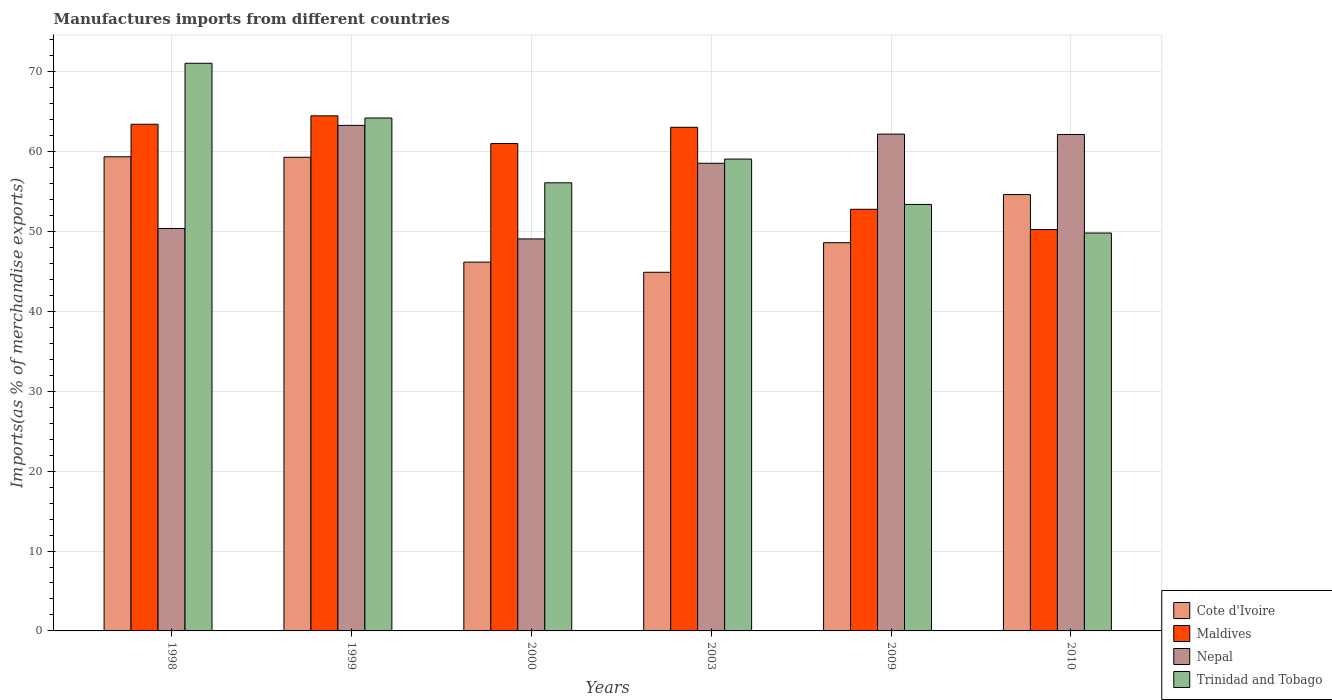How many different coloured bars are there?
Make the answer very short. 4. Are the number of bars per tick equal to the number of legend labels?
Make the answer very short. Yes. Are the number of bars on each tick of the X-axis equal?
Ensure brevity in your answer.  Yes. How many bars are there on the 5th tick from the left?
Your answer should be very brief. 4. What is the label of the 2nd group of bars from the left?
Offer a very short reply. 1999. What is the percentage of imports to different countries in Cote d'Ivoire in 2003?
Ensure brevity in your answer.  44.89. Across all years, what is the maximum percentage of imports to different countries in Cote d'Ivoire?
Offer a very short reply. 59.35. Across all years, what is the minimum percentage of imports to different countries in Nepal?
Keep it short and to the point. 49.07. In which year was the percentage of imports to different countries in Nepal maximum?
Offer a terse response. 1999. What is the total percentage of imports to different countries in Maldives in the graph?
Provide a short and direct response. 354.97. What is the difference between the percentage of imports to different countries in Nepal in 1998 and that in 1999?
Ensure brevity in your answer.  -12.9. What is the difference between the percentage of imports to different countries in Maldives in 1998 and the percentage of imports to different countries in Cote d'Ivoire in 1999?
Make the answer very short. 4.13. What is the average percentage of imports to different countries in Cote d'Ivoire per year?
Offer a terse response. 52.15. In the year 2010, what is the difference between the percentage of imports to different countries in Trinidad and Tobago and percentage of imports to different countries in Cote d'Ivoire?
Your answer should be compact. -4.81. What is the ratio of the percentage of imports to different countries in Trinidad and Tobago in 1998 to that in 2000?
Offer a terse response. 1.27. Is the difference between the percentage of imports to different countries in Trinidad and Tobago in 2009 and 2010 greater than the difference between the percentage of imports to different countries in Cote d'Ivoire in 2009 and 2010?
Provide a succinct answer. Yes. What is the difference between the highest and the second highest percentage of imports to different countries in Trinidad and Tobago?
Make the answer very short. 6.85. What is the difference between the highest and the lowest percentage of imports to different countries in Cote d'Ivoire?
Your answer should be compact. 14.46. Is it the case that in every year, the sum of the percentage of imports to different countries in Trinidad and Tobago and percentage of imports to different countries in Cote d'Ivoire is greater than the sum of percentage of imports to different countries in Maldives and percentage of imports to different countries in Nepal?
Offer a very short reply. No. What does the 3rd bar from the left in 1999 represents?
Your answer should be compact. Nepal. What does the 4th bar from the right in 1998 represents?
Give a very brief answer. Cote d'Ivoire. Is it the case that in every year, the sum of the percentage of imports to different countries in Trinidad and Tobago and percentage of imports to different countries in Cote d'Ivoire is greater than the percentage of imports to different countries in Nepal?
Offer a very short reply. Yes. How many bars are there?
Your response must be concise. 24. Are all the bars in the graph horizontal?
Your answer should be compact. No. How many years are there in the graph?
Provide a short and direct response. 6. Are the values on the major ticks of Y-axis written in scientific E-notation?
Offer a terse response. No. Does the graph contain any zero values?
Make the answer very short. No. Where does the legend appear in the graph?
Your response must be concise. Bottom right. How are the legend labels stacked?
Ensure brevity in your answer.  Vertical. What is the title of the graph?
Offer a terse response. Manufactures imports from different countries. What is the label or title of the Y-axis?
Offer a terse response. Imports(as % of merchandise exports). What is the Imports(as % of merchandise exports) of Cote d'Ivoire in 1998?
Provide a succinct answer. 59.35. What is the Imports(as % of merchandise exports) in Maldives in 1998?
Keep it short and to the point. 63.42. What is the Imports(as % of merchandise exports) in Nepal in 1998?
Your answer should be very brief. 50.38. What is the Imports(as % of merchandise exports) of Trinidad and Tobago in 1998?
Give a very brief answer. 71.06. What is the Imports(as % of merchandise exports) of Cote d'Ivoire in 1999?
Your answer should be very brief. 59.29. What is the Imports(as % of merchandise exports) in Maldives in 1999?
Give a very brief answer. 64.48. What is the Imports(as % of merchandise exports) of Nepal in 1999?
Provide a succinct answer. 63.28. What is the Imports(as % of merchandise exports) in Trinidad and Tobago in 1999?
Provide a succinct answer. 64.2. What is the Imports(as % of merchandise exports) in Cote d'Ivoire in 2000?
Provide a short and direct response. 46.16. What is the Imports(as % of merchandise exports) in Maldives in 2000?
Offer a very short reply. 61.01. What is the Imports(as % of merchandise exports) of Nepal in 2000?
Your answer should be compact. 49.07. What is the Imports(as % of merchandise exports) of Trinidad and Tobago in 2000?
Your answer should be very brief. 56.1. What is the Imports(as % of merchandise exports) of Cote d'Ivoire in 2003?
Your answer should be very brief. 44.89. What is the Imports(as % of merchandise exports) in Maldives in 2003?
Offer a very short reply. 63.04. What is the Imports(as % of merchandise exports) in Nepal in 2003?
Ensure brevity in your answer.  58.54. What is the Imports(as % of merchandise exports) of Trinidad and Tobago in 2003?
Provide a succinct answer. 59.06. What is the Imports(as % of merchandise exports) in Cote d'Ivoire in 2009?
Your response must be concise. 48.6. What is the Imports(as % of merchandise exports) of Maldives in 2009?
Provide a succinct answer. 52.78. What is the Imports(as % of merchandise exports) in Nepal in 2009?
Provide a succinct answer. 62.19. What is the Imports(as % of merchandise exports) in Trinidad and Tobago in 2009?
Your answer should be compact. 53.38. What is the Imports(as % of merchandise exports) in Cote d'Ivoire in 2010?
Provide a succinct answer. 54.62. What is the Imports(as % of merchandise exports) of Maldives in 2010?
Your response must be concise. 50.24. What is the Imports(as % of merchandise exports) in Nepal in 2010?
Provide a succinct answer. 62.14. What is the Imports(as % of merchandise exports) in Trinidad and Tobago in 2010?
Your answer should be compact. 49.81. Across all years, what is the maximum Imports(as % of merchandise exports) of Cote d'Ivoire?
Make the answer very short. 59.35. Across all years, what is the maximum Imports(as % of merchandise exports) in Maldives?
Offer a terse response. 64.48. Across all years, what is the maximum Imports(as % of merchandise exports) of Nepal?
Keep it short and to the point. 63.28. Across all years, what is the maximum Imports(as % of merchandise exports) in Trinidad and Tobago?
Keep it short and to the point. 71.06. Across all years, what is the minimum Imports(as % of merchandise exports) in Cote d'Ivoire?
Your answer should be very brief. 44.89. Across all years, what is the minimum Imports(as % of merchandise exports) of Maldives?
Your response must be concise. 50.24. Across all years, what is the minimum Imports(as % of merchandise exports) of Nepal?
Your answer should be compact. 49.07. Across all years, what is the minimum Imports(as % of merchandise exports) of Trinidad and Tobago?
Offer a terse response. 49.81. What is the total Imports(as % of merchandise exports) of Cote d'Ivoire in the graph?
Keep it short and to the point. 312.92. What is the total Imports(as % of merchandise exports) in Maldives in the graph?
Offer a terse response. 354.97. What is the total Imports(as % of merchandise exports) in Nepal in the graph?
Keep it short and to the point. 345.6. What is the total Imports(as % of merchandise exports) of Trinidad and Tobago in the graph?
Provide a succinct answer. 353.62. What is the difference between the Imports(as % of merchandise exports) in Cote d'Ivoire in 1998 and that in 1999?
Ensure brevity in your answer.  0.06. What is the difference between the Imports(as % of merchandise exports) of Maldives in 1998 and that in 1999?
Offer a terse response. -1.05. What is the difference between the Imports(as % of merchandise exports) in Nepal in 1998 and that in 1999?
Your answer should be very brief. -12.9. What is the difference between the Imports(as % of merchandise exports) in Trinidad and Tobago in 1998 and that in 1999?
Offer a very short reply. 6.85. What is the difference between the Imports(as % of merchandise exports) of Cote d'Ivoire in 1998 and that in 2000?
Offer a terse response. 13.19. What is the difference between the Imports(as % of merchandise exports) of Maldives in 1998 and that in 2000?
Offer a terse response. 2.41. What is the difference between the Imports(as % of merchandise exports) in Nepal in 1998 and that in 2000?
Make the answer very short. 1.31. What is the difference between the Imports(as % of merchandise exports) of Trinidad and Tobago in 1998 and that in 2000?
Offer a terse response. 14.96. What is the difference between the Imports(as % of merchandise exports) in Cote d'Ivoire in 1998 and that in 2003?
Keep it short and to the point. 14.46. What is the difference between the Imports(as % of merchandise exports) in Maldives in 1998 and that in 2003?
Provide a succinct answer. 0.38. What is the difference between the Imports(as % of merchandise exports) in Nepal in 1998 and that in 2003?
Provide a succinct answer. -8.16. What is the difference between the Imports(as % of merchandise exports) of Trinidad and Tobago in 1998 and that in 2003?
Offer a very short reply. 11.99. What is the difference between the Imports(as % of merchandise exports) in Cote d'Ivoire in 1998 and that in 2009?
Make the answer very short. 10.76. What is the difference between the Imports(as % of merchandise exports) of Maldives in 1998 and that in 2009?
Provide a succinct answer. 10.64. What is the difference between the Imports(as % of merchandise exports) in Nepal in 1998 and that in 2009?
Give a very brief answer. -11.81. What is the difference between the Imports(as % of merchandise exports) in Trinidad and Tobago in 1998 and that in 2009?
Make the answer very short. 17.67. What is the difference between the Imports(as % of merchandise exports) of Cote d'Ivoire in 1998 and that in 2010?
Keep it short and to the point. 4.73. What is the difference between the Imports(as % of merchandise exports) in Maldives in 1998 and that in 2010?
Your answer should be very brief. 13.18. What is the difference between the Imports(as % of merchandise exports) of Nepal in 1998 and that in 2010?
Offer a terse response. -11.77. What is the difference between the Imports(as % of merchandise exports) in Trinidad and Tobago in 1998 and that in 2010?
Provide a succinct answer. 21.25. What is the difference between the Imports(as % of merchandise exports) of Cote d'Ivoire in 1999 and that in 2000?
Your answer should be compact. 13.13. What is the difference between the Imports(as % of merchandise exports) of Maldives in 1999 and that in 2000?
Keep it short and to the point. 3.47. What is the difference between the Imports(as % of merchandise exports) of Nepal in 1999 and that in 2000?
Offer a terse response. 14.21. What is the difference between the Imports(as % of merchandise exports) of Trinidad and Tobago in 1999 and that in 2000?
Your answer should be very brief. 8.11. What is the difference between the Imports(as % of merchandise exports) of Cote d'Ivoire in 1999 and that in 2003?
Offer a very short reply. 14.4. What is the difference between the Imports(as % of merchandise exports) of Maldives in 1999 and that in 2003?
Your answer should be very brief. 1.44. What is the difference between the Imports(as % of merchandise exports) of Nepal in 1999 and that in 2003?
Provide a succinct answer. 4.74. What is the difference between the Imports(as % of merchandise exports) of Trinidad and Tobago in 1999 and that in 2003?
Your answer should be very brief. 5.14. What is the difference between the Imports(as % of merchandise exports) in Cote d'Ivoire in 1999 and that in 2009?
Provide a short and direct response. 10.69. What is the difference between the Imports(as % of merchandise exports) of Maldives in 1999 and that in 2009?
Your answer should be compact. 11.7. What is the difference between the Imports(as % of merchandise exports) of Nepal in 1999 and that in 2009?
Offer a very short reply. 1.09. What is the difference between the Imports(as % of merchandise exports) in Trinidad and Tobago in 1999 and that in 2009?
Your answer should be very brief. 10.82. What is the difference between the Imports(as % of merchandise exports) of Cote d'Ivoire in 1999 and that in 2010?
Your answer should be very brief. 4.67. What is the difference between the Imports(as % of merchandise exports) in Maldives in 1999 and that in 2010?
Offer a terse response. 14.23. What is the difference between the Imports(as % of merchandise exports) of Nepal in 1999 and that in 2010?
Your answer should be very brief. 1.14. What is the difference between the Imports(as % of merchandise exports) in Trinidad and Tobago in 1999 and that in 2010?
Provide a succinct answer. 14.39. What is the difference between the Imports(as % of merchandise exports) of Cote d'Ivoire in 2000 and that in 2003?
Ensure brevity in your answer.  1.27. What is the difference between the Imports(as % of merchandise exports) in Maldives in 2000 and that in 2003?
Your response must be concise. -2.03. What is the difference between the Imports(as % of merchandise exports) in Nepal in 2000 and that in 2003?
Your answer should be compact. -9.47. What is the difference between the Imports(as % of merchandise exports) of Trinidad and Tobago in 2000 and that in 2003?
Your response must be concise. -2.97. What is the difference between the Imports(as % of merchandise exports) of Cote d'Ivoire in 2000 and that in 2009?
Your answer should be compact. -2.43. What is the difference between the Imports(as % of merchandise exports) of Maldives in 2000 and that in 2009?
Offer a very short reply. 8.23. What is the difference between the Imports(as % of merchandise exports) of Nepal in 2000 and that in 2009?
Your answer should be compact. -13.12. What is the difference between the Imports(as % of merchandise exports) in Trinidad and Tobago in 2000 and that in 2009?
Offer a very short reply. 2.71. What is the difference between the Imports(as % of merchandise exports) of Cote d'Ivoire in 2000 and that in 2010?
Offer a very short reply. -8.46. What is the difference between the Imports(as % of merchandise exports) of Maldives in 2000 and that in 2010?
Keep it short and to the point. 10.77. What is the difference between the Imports(as % of merchandise exports) of Nepal in 2000 and that in 2010?
Offer a terse response. -13.07. What is the difference between the Imports(as % of merchandise exports) of Trinidad and Tobago in 2000 and that in 2010?
Ensure brevity in your answer.  6.28. What is the difference between the Imports(as % of merchandise exports) of Cote d'Ivoire in 2003 and that in 2009?
Ensure brevity in your answer.  -3.7. What is the difference between the Imports(as % of merchandise exports) in Maldives in 2003 and that in 2009?
Offer a very short reply. 10.26. What is the difference between the Imports(as % of merchandise exports) in Nepal in 2003 and that in 2009?
Give a very brief answer. -3.65. What is the difference between the Imports(as % of merchandise exports) of Trinidad and Tobago in 2003 and that in 2009?
Offer a terse response. 5.68. What is the difference between the Imports(as % of merchandise exports) in Cote d'Ivoire in 2003 and that in 2010?
Give a very brief answer. -9.73. What is the difference between the Imports(as % of merchandise exports) in Maldives in 2003 and that in 2010?
Offer a very short reply. 12.8. What is the difference between the Imports(as % of merchandise exports) of Nepal in 2003 and that in 2010?
Your answer should be very brief. -3.6. What is the difference between the Imports(as % of merchandise exports) of Trinidad and Tobago in 2003 and that in 2010?
Your answer should be compact. 9.25. What is the difference between the Imports(as % of merchandise exports) of Cote d'Ivoire in 2009 and that in 2010?
Make the answer very short. -6.03. What is the difference between the Imports(as % of merchandise exports) of Maldives in 2009 and that in 2010?
Give a very brief answer. 2.54. What is the difference between the Imports(as % of merchandise exports) of Nepal in 2009 and that in 2010?
Give a very brief answer. 0.04. What is the difference between the Imports(as % of merchandise exports) in Trinidad and Tobago in 2009 and that in 2010?
Offer a terse response. 3.57. What is the difference between the Imports(as % of merchandise exports) in Cote d'Ivoire in 1998 and the Imports(as % of merchandise exports) in Maldives in 1999?
Offer a terse response. -5.12. What is the difference between the Imports(as % of merchandise exports) of Cote d'Ivoire in 1998 and the Imports(as % of merchandise exports) of Nepal in 1999?
Your answer should be very brief. -3.93. What is the difference between the Imports(as % of merchandise exports) in Cote d'Ivoire in 1998 and the Imports(as % of merchandise exports) in Trinidad and Tobago in 1999?
Provide a short and direct response. -4.85. What is the difference between the Imports(as % of merchandise exports) of Maldives in 1998 and the Imports(as % of merchandise exports) of Nepal in 1999?
Your response must be concise. 0.14. What is the difference between the Imports(as % of merchandise exports) of Maldives in 1998 and the Imports(as % of merchandise exports) of Trinidad and Tobago in 1999?
Your answer should be compact. -0.78. What is the difference between the Imports(as % of merchandise exports) of Nepal in 1998 and the Imports(as % of merchandise exports) of Trinidad and Tobago in 1999?
Offer a terse response. -13.83. What is the difference between the Imports(as % of merchandise exports) of Cote d'Ivoire in 1998 and the Imports(as % of merchandise exports) of Maldives in 2000?
Ensure brevity in your answer.  -1.66. What is the difference between the Imports(as % of merchandise exports) in Cote d'Ivoire in 1998 and the Imports(as % of merchandise exports) in Nepal in 2000?
Your answer should be compact. 10.28. What is the difference between the Imports(as % of merchandise exports) in Cote d'Ivoire in 1998 and the Imports(as % of merchandise exports) in Trinidad and Tobago in 2000?
Your answer should be very brief. 3.26. What is the difference between the Imports(as % of merchandise exports) in Maldives in 1998 and the Imports(as % of merchandise exports) in Nepal in 2000?
Give a very brief answer. 14.35. What is the difference between the Imports(as % of merchandise exports) of Maldives in 1998 and the Imports(as % of merchandise exports) of Trinidad and Tobago in 2000?
Ensure brevity in your answer.  7.33. What is the difference between the Imports(as % of merchandise exports) of Nepal in 1998 and the Imports(as % of merchandise exports) of Trinidad and Tobago in 2000?
Offer a very short reply. -5.72. What is the difference between the Imports(as % of merchandise exports) in Cote d'Ivoire in 1998 and the Imports(as % of merchandise exports) in Maldives in 2003?
Ensure brevity in your answer.  -3.69. What is the difference between the Imports(as % of merchandise exports) of Cote d'Ivoire in 1998 and the Imports(as % of merchandise exports) of Nepal in 2003?
Ensure brevity in your answer.  0.81. What is the difference between the Imports(as % of merchandise exports) in Cote d'Ivoire in 1998 and the Imports(as % of merchandise exports) in Trinidad and Tobago in 2003?
Your response must be concise. 0.29. What is the difference between the Imports(as % of merchandise exports) of Maldives in 1998 and the Imports(as % of merchandise exports) of Nepal in 2003?
Keep it short and to the point. 4.88. What is the difference between the Imports(as % of merchandise exports) in Maldives in 1998 and the Imports(as % of merchandise exports) in Trinidad and Tobago in 2003?
Make the answer very short. 4.36. What is the difference between the Imports(as % of merchandise exports) in Nepal in 1998 and the Imports(as % of merchandise exports) in Trinidad and Tobago in 2003?
Keep it short and to the point. -8.69. What is the difference between the Imports(as % of merchandise exports) of Cote d'Ivoire in 1998 and the Imports(as % of merchandise exports) of Maldives in 2009?
Your response must be concise. 6.57. What is the difference between the Imports(as % of merchandise exports) in Cote d'Ivoire in 1998 and the Imports(as % of merchandise exports) in Nepal in 2009?
Give a very brief answer. -2.83. What is the difference between the Imports(as % of merchandise exports) in Cote d'Ivoire in 1998 and the Imports(as % of merchandise exports) in Trinidad and Tobago in 2009?
Provide a succinct answer. 5.97. What is the difference between the Imports(as % of merchandise exports) of Maldives in 1998 and the Imports(as % of merchandise exports) of Nepal in 2009?
Provide a short and direct response. 1.24. What is the difference between the Imports(as % of merchandise exports) in Maldives in 1998 and the Imports(as % of merchandise exports) in Trinidad and Tobago in 2009?
Ensure brevity in your answer.  10.04. What is the difference between the Imports(as % of merchandise exports) of Nepal in 1998 and the Imports(as % of merchandise exports) of Trinidad and Tobago in 2009?
Offer a very short reply. -3.01. What is the difference between the Imports(as % of merchandise exports) in Cote d'Ivoire in 1998 and the Imports(as % of merchandise exports) in Maldives in 2010?
Ensure brevity in your answer.  9.11. What is the difference between the Imports(as % of merchandise exports) of Cote d'Ivoire in 1998 and the Imports(as % of merchandise exports) of Nepal in 2010?
Your answer should be compact. -2.79. What is the difference between the Imports(as % of merchandise exports) of Cote d'Ivoire in 1998 and the Imports(as % of merchandise exports) of Trinidad and Tobago in 2010?
Offer a very short reply. 9.54. What is the difference between the Imports(as % of merchandise exports) in Maldives in 1998 and the Imports(as % of merchandise exports) in Nepal in 2010?
Your answer should be very brief. 1.28. What is the difference between the Imports(as % of merchandise exports) of Maldives in 1998 and the Imports(as % of merchandise exports) of Trinidad and Tobago in 2010?
Provide a short and direct response. 13.61. What is the difference between the Imports(as % of merchandise exports) of Nepal in 1998 and the Imports(as % of merchandise exports) of Trinidad and Tobago in 2010?
Provide a succinct answer. 0.57. What is the difference between the Imports(as % of merchandise exports) of Cote d'Ivoire in 1999 and the Imports(as % of merchandise exports) of Maldives in 2000?
Your answer should be compact. -1.72. What is the difference between the Imports(as % of merchandise exports) in Cote d'Ivoire in 1999 and the Imports(as % of merchandise exports) in Nepal in 2000?
Offer a very short reply. 10.22. What is the difference between the Imports(as % of merchandise exports) of Cote d'Ivoire in 1999 and the Imports(as % of merchandise exports) of Trinidad and Tobago in 2000?
Make the answer very short. 3.2. What is the difference between the Imports(as % of merchandise exports) in Maldives in 1999 and the Imports(as % of merchandise exports) in Nepal in 2000?
Your response must be concise. 15.41. What is the difference between the Imports(as % of merchandise exports) in Maldives in 1999 and the Imports(as % of merchandise exports) in Trinidad and Tobago in 2000?
Provide a succinct answer. 8.38. What is the difference between the Imports(as % of merchandise exports) in Nepal in 1999 and the Imports(as % of merchandise exports) in Trinidad and Tobago in 2000?
Your answer should be very brief. 7.19. What is the difference between the Imports(as % of merchandise exports) in Cote d'Ivoire in 1999 and the Imports(as % of merchandise exports) in Maldives in 2003?
Your answer should be very brief. -3.75. What is the difference between the Imports(as % of merchandise exports) of Cote d'Ivoire in 1999 and the Imports(as % of merchandise exports) of Nepal in 2003?
Offer a very short reply. 0.75. What is the difference between the Imports(as % of merchandise exports) of Cote d'Ivoire in 1999 and the Imports(as % of merchandise exports) of Trinidad and Tobago in 2003?
Your answer should be very brief. 0.23. What is the difference between the Imports(as % of merchandise exports) in Maldives in 1999 and the Imports(as % of merchandise exports) in Nepal in 2003?
Offer a terse response. 5.94. What is the difference between the Imports(as % of merchandise exports) in Maldives in 1999 and the Imports(as % of merchandise exports) in Trinidad and Tobago in 2003?
Give a very brief answer. 5.41. What is the difference between the Imports(as % of merchandise exports) in Nepal in 1999 and the Imports(as % of merchandise exports) in Trinidad and Tobago in 2003?
Ensure brevity in your answer.  4.22. What is the difference between the Imports(as % of merchandise exports) in Cote d'Ivoire in 1999 and the Imports(as % of merchandise exports) in Maldives in 2009?
Give a very brief answer. 6.51. What is the difference between the Imports(as % of merchandise exports) of Cote d'Ivoire in 1999 and the Imports(as % of merchandise exports) of Nepal in 2009?
Offer a terse response. -2.9. What is the difference between the Imports(as % of merchandise exports) in Cote d'Ivoire in 1999 and the Imports(as % of merchandise exports) in Trinidad and Tobago in 2009?
Your answer should be very brief. 5.91. What is the difference between the Imports(as % of merchandise exports) in Maldives in 1999 and the Imports(as % of merchandise exports) in Nepal in 2009?
Provide a short and direct response. 2.29. What is the difference between the Imports(as % of merchandise exports) of Maldives in 1999 and the Imports(as % of merchandise exports) of Trinidad and Tobago in 2009?
Provide a succinct answer. 11.09. What is the difference between the Imports(as % of merchandise exports) of Nepal in 1999 and the Imports(as % of merchandise exports) of Trinidad and Tobago in 2009?
Offer a terse response. 9.9. What is the difference between the Imports(as % of merchandise exports) in Cote d'Ivoire in 1999 and the Imports(as % of merchandise exports) in Maldives in 2010?
Your answer should be compact. 9.05. What is the difference between the Imports(as % of merchandise exports) of Cote d'Ivoire in 1999 and the Imports(as % of merchandise exports) of Nepal in 2010?
Offer a terse response. -2.85. What is the difference between the Imports(as % of merchandise exports) of Cote d'Ivoire in 1999 and the Imports(as % of merchandise exports) of Trinidad and Tobago in 2010?
Ensure brevity in your answer.  9.48. What is the difference between the Imports(as % of merchandise exports) of Maldives in 1999 and the Imports(as % of merchandise exports) of Nepal in 2010?
Ensure brevity in your answer.  2.33. What is the difference between the Imports(as % of merchandise exports) of Maldives in 1999 and the Imports(as % of merchandise exports) of Trinidad and Tobago in 2010?
Make the answer very short. 14.67. What is the difference between the Imports(as % of merchandise exports) of Nepal in 1999 and the Imports(as % of merchandise exports) of Trinidad and Tobago in 2010?
Offer a very short reply. 13.47. What is the difference between the Imports(as % of merchandise exports) in Cote d'Ivoire in 2000 and the Imports(as % of merchandise exports) in Maldives in 2003?
Your answer should be compact. -16.88. What is the difference between the Imports(as % of merchandise exports) in Cote d'Ivoire in 2000 and the Imports(as % of merchandise exports) in Nepal in 2003?
Provide a short and direct response. -12.38. What is the difference between the Imports(as % of merchandise exports) of Cote d'Ivoire in 2000 and the Imports(as % of merchandise exports) of Trinidad and Tobago in 2003?
Your response must be concise. -12.9. What is the difference between the Imports(as % of merchandise exports) of Maldives in 2000 and the Imports(as % of merchandise exports) of Nepal in 2003?
Make the answer very short. 2.47. What is the difference between the Imports(as % of merchandise exports) of Maldives in 2000 and the Imports(as % of merchandise exports) of Trinidad and Tobago in 2003?
Your answer should be compact. 1.94. What is the difference between the Imports(as % of merchandise exports) in Nepal in 2000 and the Imports(as % of merchandise exports) in Trinidad and Tobago in 2003?
Provide a short and direct response. -9.99. What is the difference between the Imports(as % of merchandise exports) in Cote d'Ivoire in 2000 and the Imports(as % of merchandise exports) in Maldives in 2009?
Your answer should be compact. -6.62. What is the difference between the Imports(as % of merchandise exports) in Cote d'Ivoire in 2000 and the Imports(as % of merchandise exports) in Nepal in 2009?
Provide a short and direct response. -16.02. What is the difference between the Imports(as % of merchandise exports) of Cote d'Ivoire in 2000 and the Imports(as % of merchandise exports) of Trinidad and Tobago in 2009?
Provide a short and direct response. -7.22. What is the difference between the Imports(as % of merchandise exports) of Maldives in 2000 and the Imports(as % of merchandise exports) of Nepal in 2009?
Your response must be concise. -1.18. What is the difference between the Imports(as % of merchandise exports) of Maldives in 2000 and the Imports(as % of merchandise exports) of Trinidad and Tobago in 2009?
Provide a short and direct response. 7.62. What is the difference between the Imports(as % of merchandise exports) of Nepal in 2000 and the Imports(as % of merchandise exports) of Trinidad and Tobago in 2009?
Your answer should be compact. -4.31. What is the difference between the Imports(as % of merchandise exports) of Cote d'Ivoire in 2000 and the Imports(as % of merchandise exports) of Maldives in 2010?
Ensure brevity in your answer.  -4.08. What is the difference between the Imports(as % of merchandise exports) of Cote d'Ivoire in 2000 and the Imports(as % of merchandise exports) of Nepal in 2010?
Make the answer very short. -15.98. What is the difference between the Imports(as % of merchandise exports) of Cote d'Ivoire in 2000 and the Imports(as % of merchandise exports) of Trinidad and Tobago in 2010?
Offer a terse response. -3.65. What is the difference between the Imports(as % of merchandise exports) of Maldives in 2000 and the Imports(as % of merchandise exports) of Nepal in 2010?
Keep it short and to the point. -1.13. What is the difference between the Imports(as % of merchandise exports) of Maldives in 2000 and the Imports(as % of merchandise exports) of Trinidad and Tobago in 2010?
Make the answer very short. 11.2. What is the difference between the Imports(as % of merchandise exports) of Nepal in 2000 and the Imports(as % of merchandise exports) of Trinidad and Tobago in 2010?
Your answer should be compact. -0.74. What is the difference between the Imports(as % of merchandise exports) of Cote d'Ivoire in 2003 and the Imports(as % of merchandise exports) of Maldives in 2009?
Give a very brief answer. -7.89. What is the difference between the Imports(as % of merchandise exports) in Cote d'Ivoire in 2003 and the Imports(as % of merchandise exports) in Nepal in 2009?
Your answer should be compact. -17.29. What is the difference between the Imports(as % of merchandise exports) in Cote d'Ivoire in 2003 and the Imports(as % of merchandise exports) in Trinidad and Tobago in 2009?
Provide a succinct answer. -8.49. What is the difference between the Imports(as % of merchandise exports) of Maldives in 2003 and the Imports(as % of merchandise exports) of Nepal in 2009?
Offer a very short reply. 0.85. What is the difference between the Imports(as % of merchandise exports) in Maldives in 2003 and the Imports(as % of merchandise exports) in Trinidad and Tobago in 2009?
Your answer should be compact. 9.66. What is the difference between the Imports(as % of merchandise exports) in Nepal in 2003 and the Imports(as % of merchandise exports) in Trinidad and Tobago in 2009?
Make the answer very short. 5.16. What is the difference between the Imports(as % of merchandise exports) in Cote d'Ivoire in 2003 and the Imports(as % of merchandise exports) in Maldives in 2010?
Your answer should be compact. -5.35. What is the difference between the Imports(as % of merchandise exports) of Cote d'Ivoire in 2003 and the Imports(as % of merchandise exports) of Nepal in 2010?
Your response must be concise. -17.25. What is the difference between the Imports(as % of merchandise exports) in Cote d'Ivoire in 2003 and the Imports(as % of merchandise exports) in Trinidad and Tobago in 2010?
Give a very brief answer. -4.92. What is the difference between the Imports(as % of merchandise exports) in Maldives in 2003 and the Imports(as % of merchandise exports) in Nepal in 2010?
Make the answer very short. 0.9. What is the difference between the Imports(as % of merchandise exports) in Maldives in 2003 and the Imports(as % of merchandise exports) in Trinidad and Tobago in 2010?
Ensure brevity in your answer.  13.23. What is the difference between the Imports(as % of merchandise exports) in Nepal in 2003 and the Imports(as % of merchandise exports) in Trinidad and Tobago in 2010?
Provide a short and direct response. 8.73. What is the difference between the Imports(as % of merchandise exports) in Cote d'Ivoire in 2009 and the Imports(as % of merchandise exports) in Maldives in 2010?
Offer a very short reply. -1.65. What is the difference between the Imports(as % of merchandise exports) in Cote d'Ivoire in 2009 and the Imports(as % of merchandise exports) in Nepal in 2010?
Give a very brief answer. -13.55. What is the difference between the Imports(as % of merchandise exports) of Cote d'Ivoire in 2009 and the Imports(as % of merchandise exports) of Trinidad and Tobago in 2010?
Provide a succinct answer. -1.21. What is the difference between the Imports(as % of merchandise exports) of Maldives in 2009 and the Imports(as % of merchandise exports) of Nepal in 2010?
Provide a short and direct response. -9.36. What is the difference between the Imports(as % of merchandise exports) of Maldives in 2009 and the Imports(as % of merchandise exports) of Trinidad and Tobago in 2010?
Offer a very short reply. 2.97. What is the difference between the Imports(as % of merchandise exports) of Nepal in 2009 and the Imports(as % of merchandise exports) of Trinidad and Tobago in 2010?
Your answer should be compact. 12.38. What is the average Imports(as % of merchandise exports) of Cote d'Ivoire per year?
Provide a short and direct response. 52.15. What is the average Imports(as % of merchandise exports) in Maldives per year?
Keep it short and to the point. 59.16. What is the average Imports(as % of merchandise exports) of Nepal per year?
Provide a succinct answer. 57.6. What is the average Imports(as % of merchandise exports) of Trinidad and Tobago per year?
Your answer should be very brief. 58.94. In the year 1998, what is the difference between the Imports(as % of merchandise exports) of Cote d'Ivoire and Imports(as % of merchandise exports) of Maldives?
Offer a terse response. -4.07. In the year 1998, what is the difference between the Imports(as % of merchandise exports) in Cote d'Ivoire and Imports(as % of merchandise exports) in Nepal?
Your response must be concise. 8.98. In the year 1998, what is the difference between the Imports(as % of merchandise exports) in Cote d'Ivoire and Imports(as % of merchandise exports) in Trinidad and Tobago?
Keep it short and to the point. -11.71. In the year 1998, what is the difference between the Imports(as % of merchandise exports) in Maldives and Imports(as % of merchandise exports) in Nepal?
Your response must be concise. 13.04. In the year 1998, what is the difference between the Imports(as % of merchandise exports) of Maldives and Imports(as % of merchandise exports) of Trinidad and Tobago?
Provide a short and direct response. -7.64. In the year 1998, what is the difference between the Imports(as % of merchandise exports) in Nepal and Imports(as % of merchandise exports) in Trinidad and Tobago?
Your answer should be compact. -20.68. In the year 1999, what is the difference between the Imports(as % of merchandise exports) of Cote d'Ivoire and Imports(as % of merchandise exports) of Maldives?
Offer a terse response. -5.19. In the year 1999, what is the difference between the Imports(as % of merchandise exports) in Cote d'Ivoire and Imports(as % of merchandise exports) in Nepal?
Provide a short and direct response. -3.99. In the year 1999, what is the difference between the Imports(as % of merchandise exports) of Cote d'Ivoire and Imports(as % of merchandise exports) of Trinidad and Tobago?
Offer a very short reply. -4.91. In the year 1999, what is the difference between the Imports(as % of merchandise exports) in Maldives and Imports(as % of merchandise exports) in Nepal?
Give a very brief answer. 1.19. In the year 1999, what is the difference between the Imports(as % of merchandise exports) of Maldives and Imports(as % of merchandise exports) of Trinidad and Tobago?
Your response must be concise. 0.27. In the year 1999, what is the difference between the Imports(as % of merchandise exports) of Nepal and Imports(as % of merchandise exports) of Trinidad and Tobago?
Give a very brief answer. -0.92. In the year 2000, what is the difference between the Imports(as % of merchandise exports) of Cote d'Ivoire and Imports(as % of merchandise exports) of Maldives?
Provide a short and direct response. -14.85. In the year 2000, what is the difference between the Imports(as % of merchandise exports) in Cote d'Ivoire and Imports(as % of merchandise exports) in Nepal?
Your answer should be compact. -2.91. In the year 2000, what is the difference between the Imports(as % of merchandise exports) in Cote d'Ivoire and Imports(as % of merchandise exports) in Trinidad and Tobago?
Provide a short and direct response. -9.93. In the year 2000, what is the difference between the Imports(as % of merchandise exports) of Maldives and Imports(as % of merchandise exports) of Nepal?
Give a very brief answer. 11.94. In the year 2000, what is the difference between the Imports(as % of merchandise exports) of Maldives and Imports(as % of merchandise exports) of Trinidad and Tobago?
Keep it short and to the point. 4.91. In the year 2000, what is the difference between the Imports(as % of merchandise exports) in Nepal and Imports(as % of merchandise exports) in Trinidad and Tobago?
Make the answer very short. -7.03. In the year 2003, what is the difference between the Imports(as % of merchandise exports) in Cote d'Ivoire and Imports(as % of merchandise exports) in Maldives?
Keep it short and to the point. -18.15. In the year 2003, what is the difference between the Imports(as % of merchandise exports) of Cote d'Ivoire and Imports(as % of merchandise exports) of Nepal?
Ensure brevity in your answer.  -13.65. In the year 2003, what is the difference between the Imports(as % of merchandise exports) in Cote d'Ivoire and Imports(as % of merchandise exports) in Trinidad and Tobago?
Make the answer very short. -14.17. In the year 2003, what is the difference between the Imports(as % of merchandise exports) of Maldives and Imports(as % of merchandise exports) of Nepal?
Give a very brief answer. 4.5. In the year 2003, what is the difference between the Imports(as % of merchandise exports) in Maldives and Imports(as % of merchandise exports) in Trinidad and Tobago?
Offer a very short reply. 3.98. In the year 2003, what is the difference between the Imports(as % of merchandise exports) of Nepal and Imports(as % of merchandise exports) of Trinidad and Tobago?
Your answer should be very brief. -0.52. In the year 2009, what is the difference between the Imports(as % of merchandise exports) of Cote d'Ivoire and Imports(as % of merchandise exports) of Maldives?
Your answer should be compact. -4.18. In the year 2009, what is the difference between the Imports(as % of merchandise exports) in Cote d'Ivoire and Imports(as % of merchandise exports) in Nepal?
Ensure brevity in your answer.  -13.59. In the year 2009, what is the difference between the Imports(as % of merchandise exports) in Cote d'Ivoire and Imports(as % of merchandise exports) in Trinidad and Tobago?
Ensure brevity in your answer.  -4.79. In the year 2009, what is the difference between the Imports(as % of merchandise exports) in Maldives and Imports(as % of merchandise exports) in Nepal?
Your response must be concise. -9.41. In the year 2009, what is the difference between the Imports(as % of merchandise exports) of Maldives and Imports(as % of merchandise exports) of Trinidad and Tobago?
Your response must be concise. -0.61. In the year 2009, what is the difference between the Imports(as % of merchandise exports) in Nepal and Imports(as % of merchandise exports) in Trinidad and Tobago?
Your answer should be very brief. 8.8. In the year 2010, what is the difference between the Imports(as % of merchandise exports) in Cote d'Ivoire and Imports(as % of merchandise exports) in Maldives?
Ensure brevity in your answer.  4.38. In the year 2010, what is the difference between the Imports(as % of merchandise exports) in Cote d'Ivoire and Imports(as % of merchandise exports) in Nepal?
Your answer should be very brief. -7.52. In the year 2010, what is the difference between the Imports(as % of merchandise exports) of Cote d'Ivoire and Imports(as % of merchandise exports) of Trinidad and Tobago?
Give a very brief answer. 4.81. In the year 2010, what is the difference between the Imports(as % of merchandise exports) of Maldives and Imports(as % of merchandise exports) of Nepal?
Offer a terse response. -11.9. In the year 2010, what is the difference between the Imports(as % of merchandise exports) in Maldives and Imports(as % of merchandise exports) in Trinidad and Tobago?
Your response must be concise. 0.43. In the year 2010, what is the difference between the Imports(as % of merchandise exports) of Nepal and Imports(as % of merchandise exports) of Trinidad and Tobago?
Provide a short and direct response. 12.33. What is the ratio of the Imports(as % of merchandise exports) in Maldives in 1998 to that in 1999?
Your answer should be compact. 0.98. What is the ratio of the Imports(as % of merchandise exports) of Nepal in 1998 to that in 1999?
Keep it short and to the point. 0.8. What is the ratio of the Imports(as % of merchandise exports) of Trinidad and Tobago in 1998 to that in 1999?
Provide a succinct answer. 1.11. What is the ratio of the Imports(as % of merchandise exports) in Cote d'Ivoire in 1998 to that in 2000?
Offer a very short reply. 1.29. What is the ratio of the Imports(as % of merchandise exports) in Maldives in 1998 to that in 2000?
Give a very brief answer. 1.04. What is the ratio of the Imports(as % of merchandise exports) in Nepal in 1998 to that in 2000?
Your answer should be compact. 1.03. What is the ratio of the Imports(as % of merchandise exports) in Trinidad and Tobago in 1998 to that in 2000?
Ensure brevity in your answer.  1.27. What is the ratio of the Imports(as % of merchandise exports) of Cote d'Ivoire in 1998 to that in 2003?
Give a very brief answer. 1.32. What is the ratio of the Imports(as % of merchandise exports) of Nepal in 1998 to that in 2003?
Make the answer very short. 0.86. What is the ratio of the Imports(as % of merchandise exports) in Trinidad and Tobago in 1998 to that in 2003?
Make the answer very short. 1.2. What is the ratio of the Imports(as % of merchandise exports) in Cote d'Ivoire in 1998 to that in 2009?
Your answer should be compact. 1.22. What is the ratio of the Imports(as % of merchandise exports) in Maldives in 1998 to that in 2009?
Ensure brevity in your answer.  1.2. What is the ratio of the Imports(as % of merchandise exports) in Nepal in 1998 to that in 2009?
Your answer should be compact. 0.81. What is the ratio of the Imports(as % of merchandise exports) of Trinidad and Tobago in 1998 to that in 2009?
Ensure brevity in your answer.  1.33. What is the ratio of the Imports(as % of merchandise exports) of Cote d'Ivoire in 1998 to that in 2010?
Ensure brevity in your answer.  1.09. What is the ratio of the Imports(as % of merchandise exports) of Maldives in 1998 to that in 2010?
Your response must be concise. 1.26. What is the ratio of the Imports(as % of merchandise exports) in Nepal in 1998 to that in 2010?
Keep it short and to the point. 0.81. What is the ratio of the Imports(as % of merchandise exports) of Trinidad and Tobago in 1998 to that in 2010?
Keep it short and to the point. 1.43. What is the ratio of the Imports(as % of merchandise exports) of Cote d'Ivoire in 1999 to that in 2000?
Offer a terse response. 1.28. What is the ratio of the Imports(as % of merchandise exports) of Maldives in 1999 to that in 2000?
Your response must be concise. 1.06. What is the ratio of the Imports(as % of merchandise exports) of Nepal in 1999 to that in 2000?
Your answer should be very brief. 1.29. What is the ratio of the Imports(as % of merchandise exports) of Trinidad and Tobago in 1999 to that in 2000?
Your response must be concise. 1.14. What is the ratio of the Imports(as % of merchandise exports) in Cote d'Ivoire in 1999 to that in 2003?
Your answer should be very brief. 1.32. What is the ratio of the Imports(as % of merchandise exports) in Maldives in 1999 to that in 2003?
Make the answer very short. 1.02. What is the ratio of the Imports(as % of merchandise exports) of Nepal in 1999 to that in 2003?
Your response must be concise. 1.08. What is the ratio of the Imports(as % of merchandise exports) in Trinidad and Tobago in 1999 to that in 2003?
Give a very brief answer. 1.09. What is the ratio of the Imports(as % of merchandise exports) of Cote d'Ivoire in 1999 to that in 2009?
Provide a succinct answer. 1.22. What is the ratio of the Imports(as % of merchandise exports) of Maldives in 1999 to that in 2009?
Your response must be concise. 1.22. What is the ratio of the Imports(as % of merchandise exports) of Nepal in 1999 to that in 2009?
Your answer should be very brief. 1.02. What is the ratio of the Imports(as % of merchandise exports) in Trinidad and Tobago in 1999 to that in 2009?
Make the answer very short. 1.2. What is the ratio of the Imports(as % of merchandise exports) of Cote d'Ivoire in 1999 to that in 2010?
Provide a succinct answer. 1.09. What is the ratio of the Imports(as % of merchandise exports) of Maldives in 1999 to that in 2010?
Offer a terse response. 1.28. What is the ratio of the Imports(as % of merchandise exports) of Nepal in 1999 to that in 2010?
Make the answer very short. 1.02. What is the ratio of the Imports(as % of merchandise exports) of Trinidad and Tobago in 1999 to that in 2010?
Your response must be concise. 1.29. What is the ratio of the Imports(as % of merchandise exports) of Cote d'Ivoire in 2000 to that in 2003?
Your answer should be very brief. 1.03. What is the ratio of the Imports(as % of merchandise exports) in Maldives in 2000 to that in 2003?
Provide a short and direct response. 0.97. What is the ratio of the Imports(as % of merchandise exports) in Nepal in 2000 to that in 2003?
Give a very brief answer. 0.84. What is the ratio of the Imports(as % of merchandise exports) of Trinidad and Tobago in 2000 to that in 2003?
Ensure brevity in your answer.  0.95. What is the ratio of the Imports(as % of merchandise exports) in Cote d'Ivoire in 2000 to that in 2009?
Provide a succinct answer. 0.95. What is the ratio of the Imports(as % of merchandise exports) of Maldives in 2000 to that in 2009?
Keep it short and to the point. 1.16. What is the ratio of the Imports(as % of merchandise exports) in Nepal in 2000 to that in 2009?
Your answer should be compact. 0.79. What is the ratio of the Imports(as % of merchandise exports) in Trinidad and Tobago in 2000 to that in 2009?
Your answer should be compact. 1.05. What is the ratio of the Imports(as % of merchandise exports) in Cote d'Ivoire in 2000 to that in 2010?
Provide a succinct answer. 0.85. What is the ratio of the Imports(as % of merchandise exports) in Maldives in 2000 to that in 2010?
Provide a succinct answer. 1.21. What is the ratio of the Imports(as % of merchandise exports) of Nepal in 2000 to that in 2010?
Your answer should be compact. 0.79. What is the ratio of the Imports(as % of merchandise exports) of Trinidad and Tobago in 2000 to that in 2010?
Offer a terse response. 1.13. What is the ratio of the Imports(as % of merchandise exports) in Cote d'Ivoire in 2003 to that in 2009?
Offer a terse response. 0.92. What is the ratio of the Imports(as % of merchandise exports) in Maldives in 2003 to that in 2009?
Provide a succinct answer. 1.19. What is the ratio of the Imports(as % of merchandise exports) of Nepal in 2003 to that in 2009?
Ensure brevity in your answer.  0.94. What is the ratio of the Imports(as % of merchandise exports) of Trinidad and Tobago in 2003 to that in 2009?
Your answer should be compact. 1.11. What is the ratio of the Imports(as % of merchandise exports) of Cote d'Ivoire in 2003 to that in 2010?
Offer a very short reply. 0.82. What is the ratio of the Imports(as % of merchandise exports) of Maldives in 2003 to that in 2010?
Offer a terse response. 1.25. What is the ratio of the Imports(as % of merchandise exports) of Nepal in 2003 to that in 2010?
Provide a short and direct response. 0.94. What is the ratio of the Imports(as % of merchandise exports) in Trinidad and Tobago in 2003 to that in 2010?
Offer a very short reply. 1.19. What is the ratio of the Imports(as % of merchandise exports) of Cote d'Ivoire in 2009 to that in 2010?
Provide a succinct answer. 0.89. What is the ratio of the Imports(as % of merchandise exports) of Maldives in 2009 to that in 2010?
Keep it short and to the point. 1.05. What is the ratio of the Imports(as % of merchandise exports) of Trinidad and Tobago in 2009 to that in 2010?
Give a very brief answer. 1.07. What is the difference between the highest and the second highest Imports(as % of merchandise exports) in Cote d'Ivoire?
Provide a succinct answer. 0.06. What is the difference between the highest and the second highest Imports(as % of merchandise exports) in Maldives?
Your answer should be very brief. 1.05. What is the difference between the highest and the second highest Imports(as % of merchandise exports) in Nepal?
Offer a terse response. 1.09. What is the difference between the highest and the second highest Imports(as % of merchandise exports) in Trinidad and Tobago?
Make the answer very short. 6.85. What is the difference between the highest and the lowest Imports(as % of merchandise exports) in Cote d'Ivoire?
Provide a short and direct response. 14.46. What is the difference between the highest and the lowest Imports(as % of merchandise exports) of Maldives?
Your answer should be very brief. 14.23. What is the difference between the highest and the lowest Imports(as % of merchandise exports) of Nepal?
Make the answer very short. 14.21. What is the difference between the highest and the lowest Imports(as % of merchandise exports) of Trinidad and Tobago?
Make the answer very short. 21.25. 